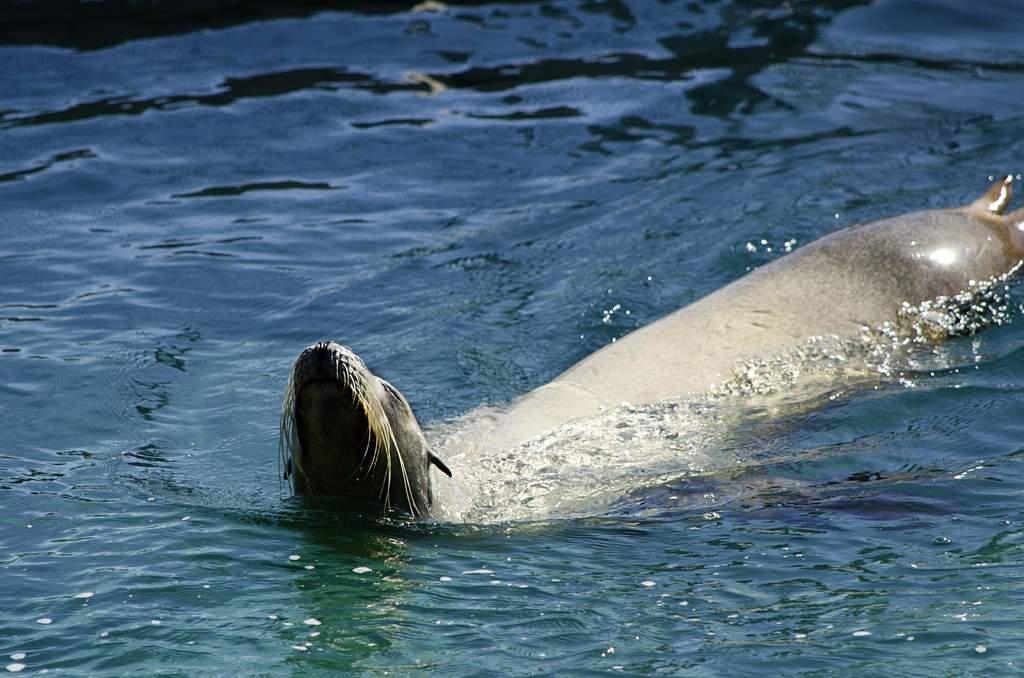How would you summarize this image in a sentence or two? In this image there is a seal in the water. 